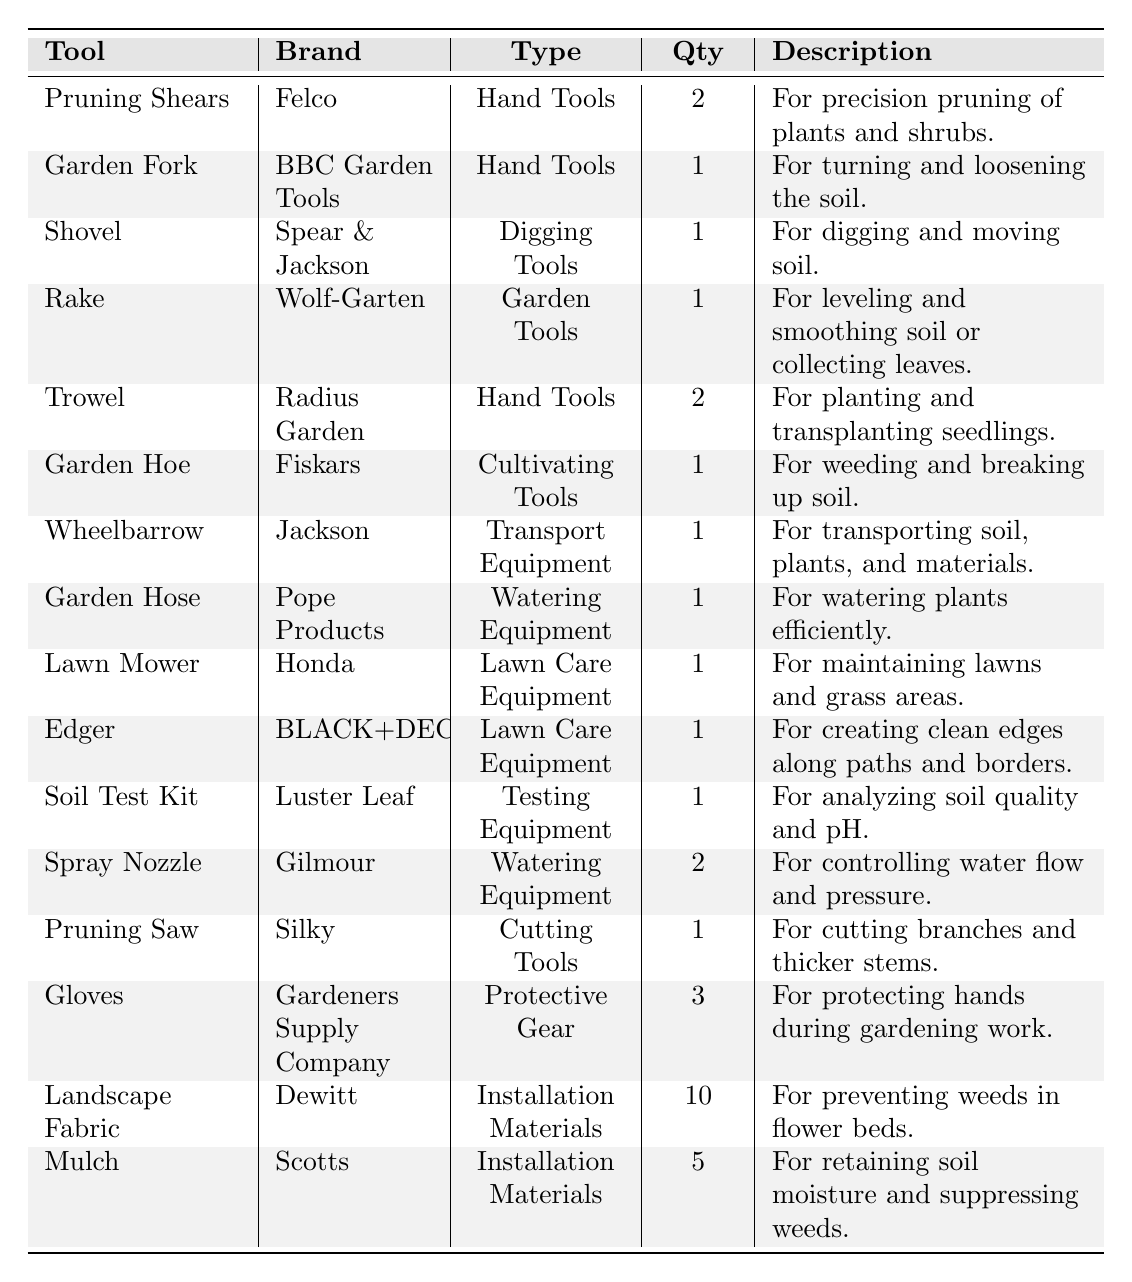What is the quantity of "Pruning Shears" in the inventory? The table lists "Pruning Shears" with a quantity of 2.
Answer: 2 How many different types of tools are there in the inventory? By counting the unique "Type" values in the table, we find there are 8 types: Hand Tools, Digging Tools, Garden Tools, Cultivating Tools, Transport Equipment, Watering Equipment, Lawn Care Equipment, Testing Equipment, Protective Gear, and Installation Materials.
Answer: 10 What brand makes the "Lawn Mower"? The "Lawn Mower" in the inventory is from the brand Honda.
Answer: Honda Which tools have a quantity of more than 2? "Gloves" have a quantity of 3 and "Landscape Fabric" has a quantity of 10, both above 2.
Answer: Gloves and Landscape Fabric What is the total quantity of installation materials in the inventory? Adding the quantity of "Landscape Fabric" (10) and "Mulch" (5) gives 10 + 5 = 15 as the total quantity of installation materials.
Answer: 15 Is "Garden Fork" categorized under Digging Tools? The table categorizes "Garden Fork" as "Hand Tools," not as "Digging Tools." Therefore, the statement is false.
Answer: No Which tool has the highest quantity, and what is that quantity? "Landscape Fabric" has the highest quantity at 10, compared to other tools.
Answer: 10 Are there more hand tools than lawn care equipment in the inventory? There are 5 hand tools (Pruning Shears, Garden Fork, Trowel, Rake, Garden Hoe) and 2 lawn care equipment (Lawn Mower, Edger). Hence, there are more hand tools.
Answer: Yes List all the tools that can be classified as "Watering Equipment"? The table lists "Garden Hose" and "Spray Nozzle" as the tools classified under "Watering Equipment."
Answer: Garden Hose and Spray Nozzle What is the total number of gardening tools in the inventory? The total number of gardening tools is derived from the counts of each type: Hand Tools (5), Digging Tools (1), Garden Tools (1), Cultivating Tools (1), and Protective Gear (3), summing to 11.
Answer: 11 